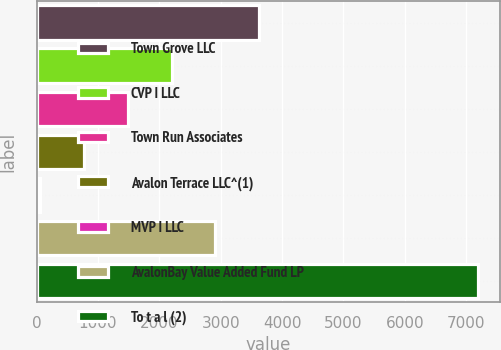Convert chart. <chart><loc_0><loc_0><loc_500><loc_500><bar_chart><fcel>Town Grove LLC<fcel>CVP I LLC<fcel>Town Run Associates<fcel>Avalon Terrace LLC^(1)<fcel>MVP I LLC<fcel>AvalonBay Value Added Fund LP<fcel>To t a l (2)<nl><fcel>3627.5<fcel>2199.3<fcel>1485.2<fcel>771.1<fcel>57<fcel>2913.4<fcel>7198<nl></chart> 